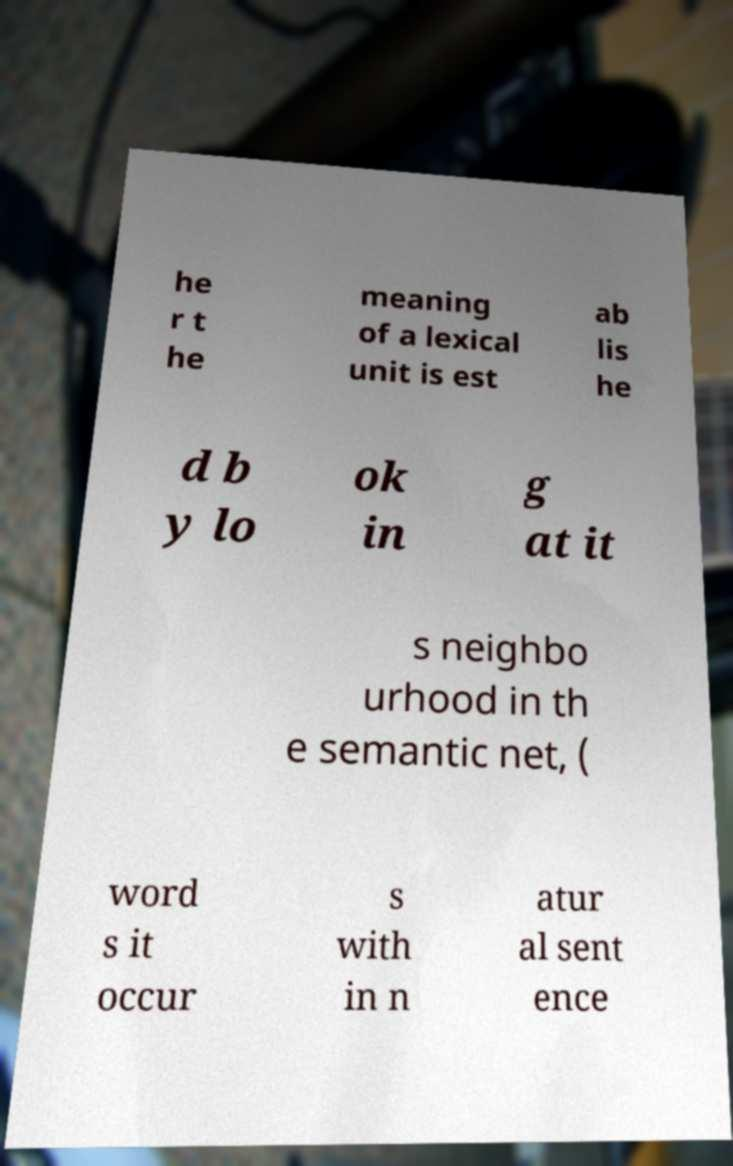Please identify and transcribe the text found in this image. he r t he meaning of a lexical unit is est ab lis he d b y lo ok in g at it s neighbo urhood in th e semantic net, ( word s it occur s with in n atur al sent ence 